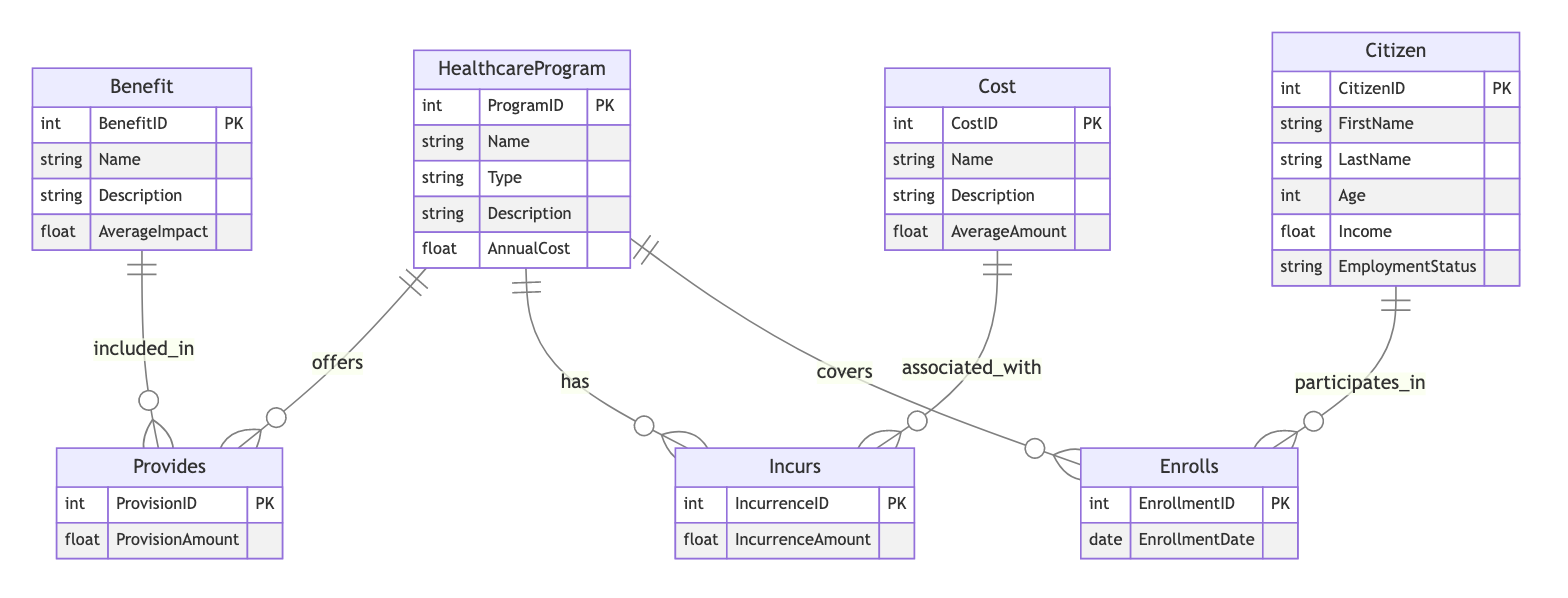What are the two types of healthcare programs? The diagram shows two healthcare programs under the entity HealthcareProgram, identified by their names: Universal Healthcare and Private Insurance.
Answer: Universal Healthcare, Private Insurance How many benefits are associated with healthcare programs? The diagram lists three benefits under the entity Benefit: Total Coverage, Preventive Care, and Mental Health Services. These benefits are linked to healthcare programs.
Answer: 3 Which relationship connects citizens to healthcare programs? The relationship that connects the Citizen entity to the HealthcareProgram entity is called Enrolls. This indicates that citizens participate in healthcare programs.
Answer: Enrolls What costs are incurred by healthcare programs? The diagram includes four costs under the Cost entity: Administrative Cost, Tax Burden, Premiums, and Out-Of-Pocket Expenses. These are associated with healthcare programs through the Incurs relationship.
Answer: 4 What is the average impact of Total Coverage benefit? The diagram shows an attribute of the Benefit entity indicating the AverageImpact for Total Coverage, which is a numerical value representing its effectiveness, but the specific value is not provided in the data.
Answer: Not provided Which healthcare program has the highest annual cost? The diagram does not provide specific annual cost values for each healthcare program, so determining which program has the highest annual cost requires additional data.
Answer: Not determinable How many distinct citizen attributes are there? The diagram outlines six distinct attributes under the Citizen entity: CitizenID, FirstName, LastName, Age, Income, and EmploymentStatus. This information indicates the characteristics of citizens participating in healthcare programs.
Answer: 6 What relationship provides benefits included in healthcare programs? The relationship that denotes the connection between the Benefit and HealthcareProgram entities for the provision of benefits is also named Provides. This indicates that benefits are part of specific healthcare programs.
Answer: Provides What attribute connects costs to healthcare programs? The attribute connecting costs to healthcare programs through the Incurs relationship is named IncurrenceAmount, which signifies the amount associated with the costs incurred by each healthcare program.
Answer: IncurrenceAmount 